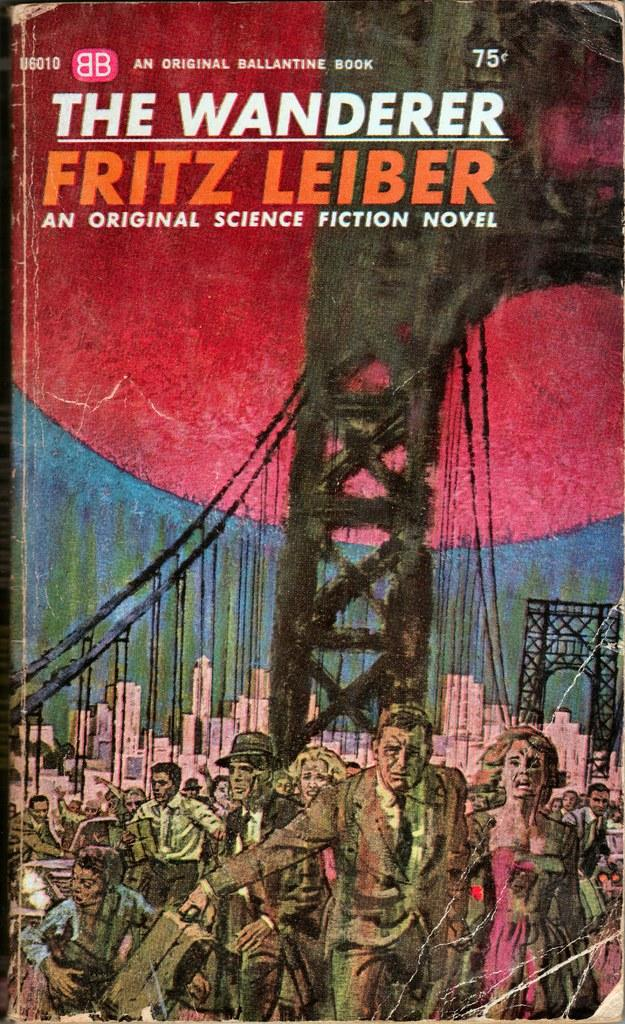Provide a one-sentence caption for the provided image. the wanderer book is a science fiction novel with an image of a burning bridge on it. 